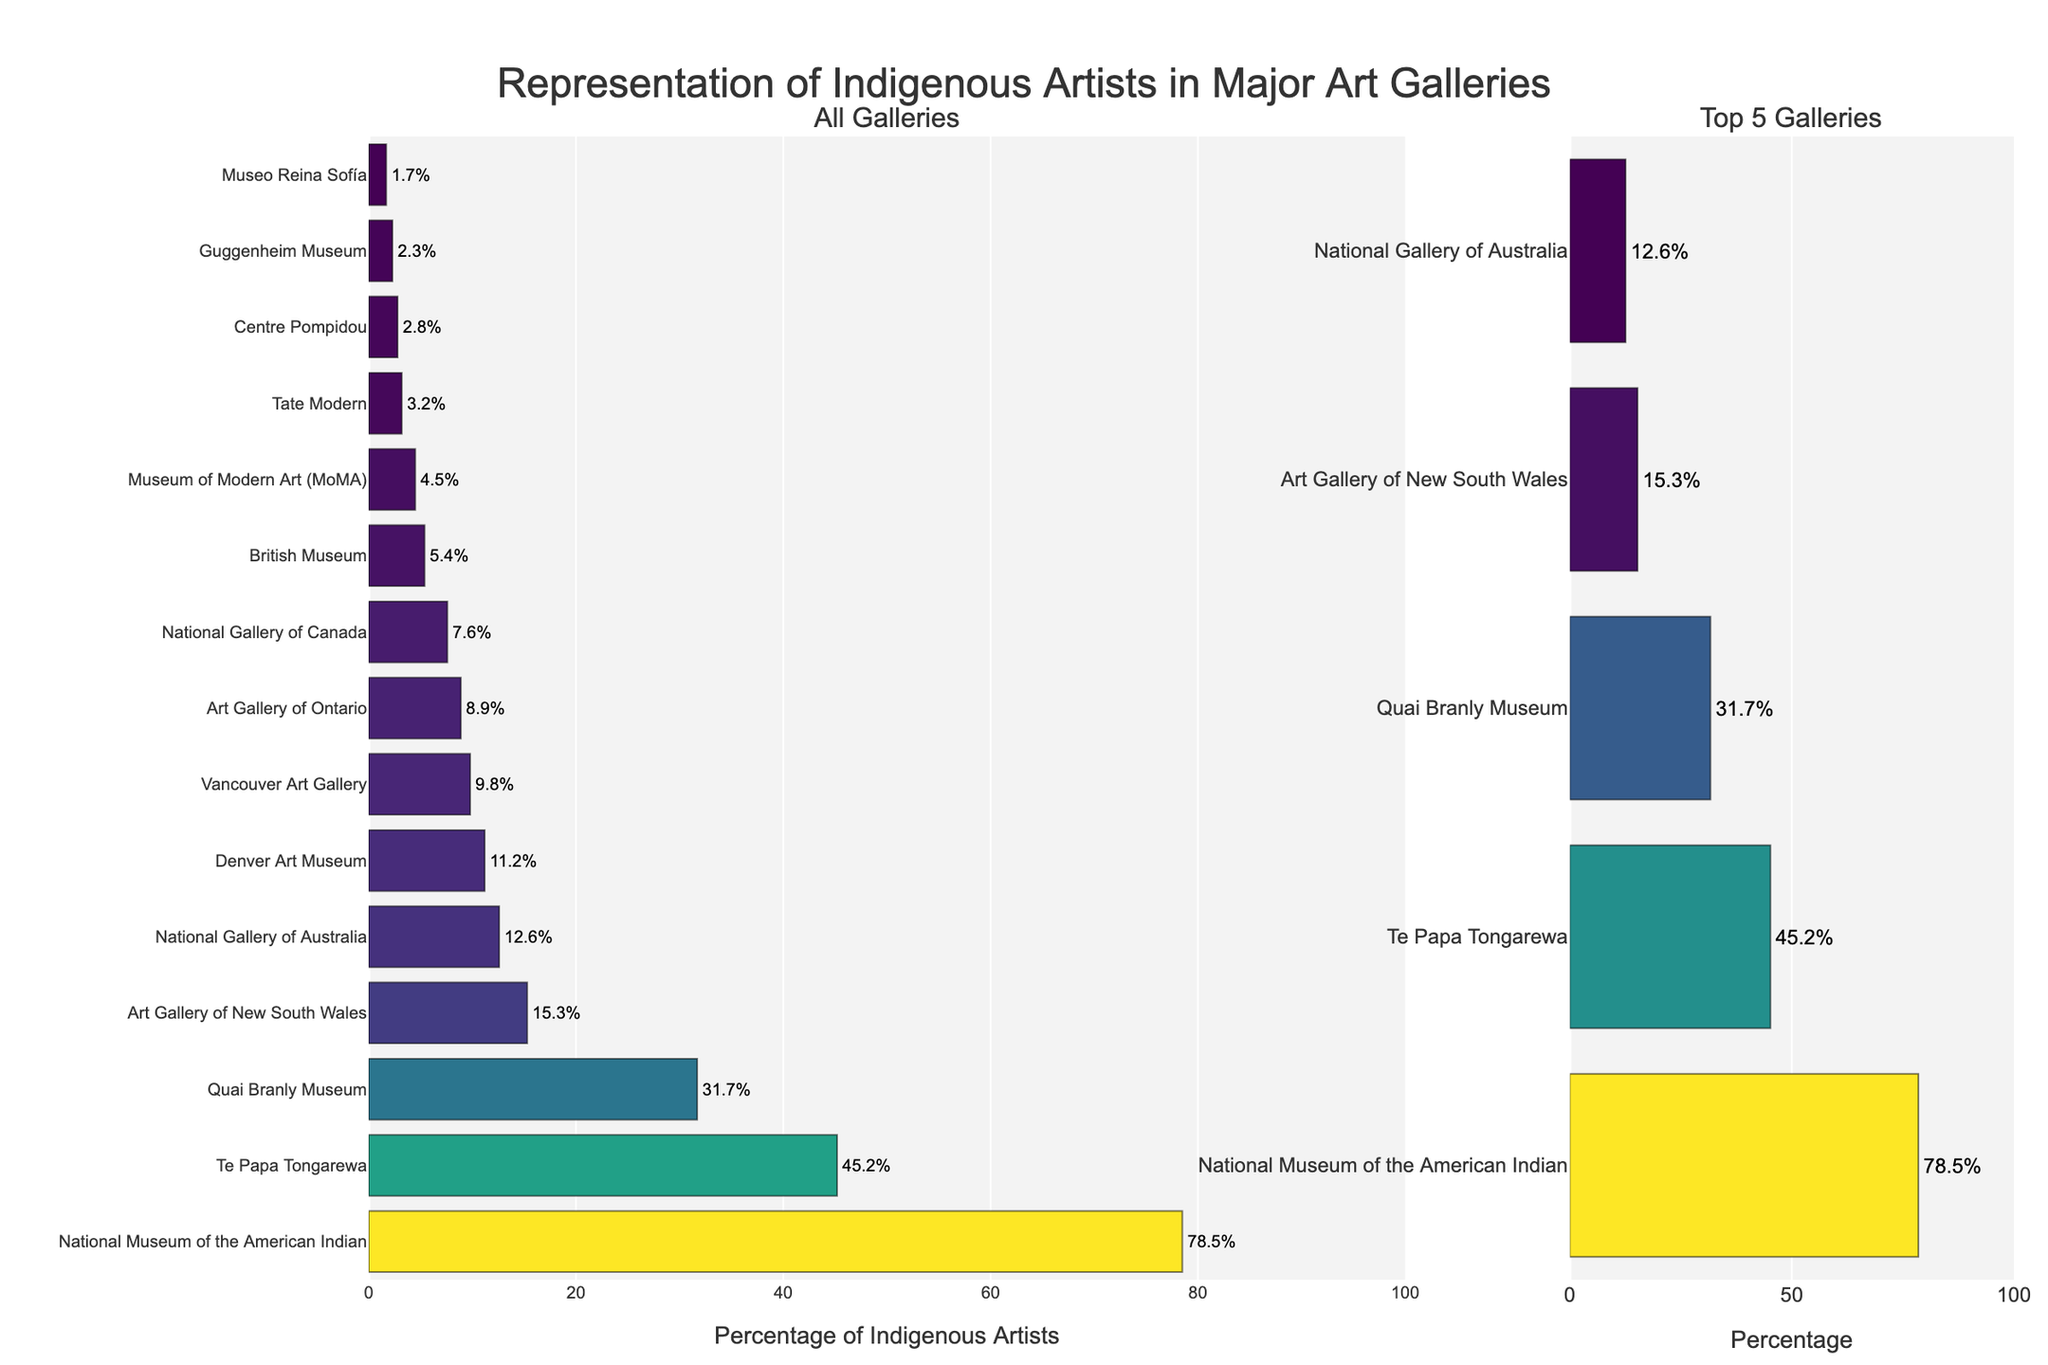What's the name of the gallery with the highest percentage of indigenous artists? Look at the bar on the "All Galleries" subplot that extends the farthest to the right. The gallery name associated with this bar is the one with the highest percentage.
Answer: National Museum of the American Indian How many galleries have more than 10% representation of indigenous artists? Count each bar in the "All Galleries" subplot that extends beyond the 10% mark on the x-axis.
Answer: 5 Which gallery has a lower percentage of indigenous artists: Tate Modern or British Museum? Compare the length of the bars representing Tate Modern and the British Museum in the "All Galleries" subplot.
Answer: Tate Modern What's the total percentage representation of indigenous artists in the top 3 galleries? Identify the top 3 bars in the "All Galleries" subplot by length and sum their percentage values: National Museum of the American Indian (78.5%), Te Papa Tongarewa (45.2%), Quai Branly Museum (31.7%). Sum = 78.5 + 45.2 + 31.7
Answer: 155.4 Which galleries appear in the "Top 5 Galleries" subplot? Look at the labels on the y-axis of the "Top 5 Galleries" subplot to identify the galleries included.
Answer: National Museum of the American Indian, Te Papa Tongarewa, Quai Branly Museum, Art Gallery of New South Wales, National Gallery of Australia What is the combined percentage representation of indigenous artists in MoMA and Guggenheim Museum? Find and sum the two percentage values: MoMA (4.5%) and Guggenheim Museum (2.3%). Sum = 4.5 + 2.3
Answer: 6.8 Is the British Museum's representation higher or lower than the Guggenheim Museum's representation? Compare the lengths of the bars for British Museum (5.4%) and the Guggenheim Museum (2.3%) in the "All Galleries" subplot.
Answer: Higher Which gallery in the "Top 5 Galleries" subplot has the lowest percentage of indigenous artists? Among the five bars in the "Top 5 Galleries" subplot, identify the shortest one.
Answer: National Gallery of Australia What's the difference in percentage representation between the gallery with the highest percentage and the gallery with the lowest percentage? Identify the galleries with the highest (National Museum of the American Indian, 78.5%) and the lowest (Museo Reina Sofía, 1.7%) percentages, then subtract the lower percentage from the higher one: 78.5 - 1.7
Answer: 76.8 What's the average percentage representation of indigenous artists in the top 5 galleries? Identify the top 5 percentages in the "All Galleries" subplot, sum them, and divide by 5: (78.5 + 45.2 + 31.7 + 15.3 + 12.6) / 5. Sum = 183.3. Average = 183.3 / 5
Answer: 36.66 